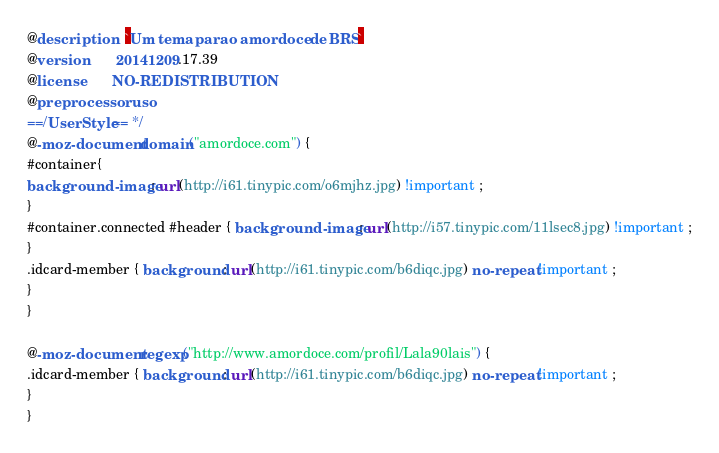Convert code to text. <code><loc_0><loc_0><loc_500><loc_500><_CSS_>@description    `Um tema para o amor doce de BRS`
@version        20141209.17.39
@license        NO-REDISTRIBUTION
@preprocessor   uso
==/UserStyle== */
@-moz-document domain("amordoce.com") {
#container{
background-image : url(http://i61.tinypic.com/o6mjhz.jpg) !important ;
}
#container.connected #header { background-image : url(http://i57.tinypic.com/11lsec8.jpg) !important ;
}
.idcard-member { background : url(http://i61.tinypic.com/b6diqc.jpg) no-repeat !important ;
}
}

@-moz-document regexp("http://www.amordoce.com/profil/Lala90lais") {
.idcard-member { background : url(http://i61.tinypic.com/b6diqc.jpg) no-repeat !important ;
}
}</code> 